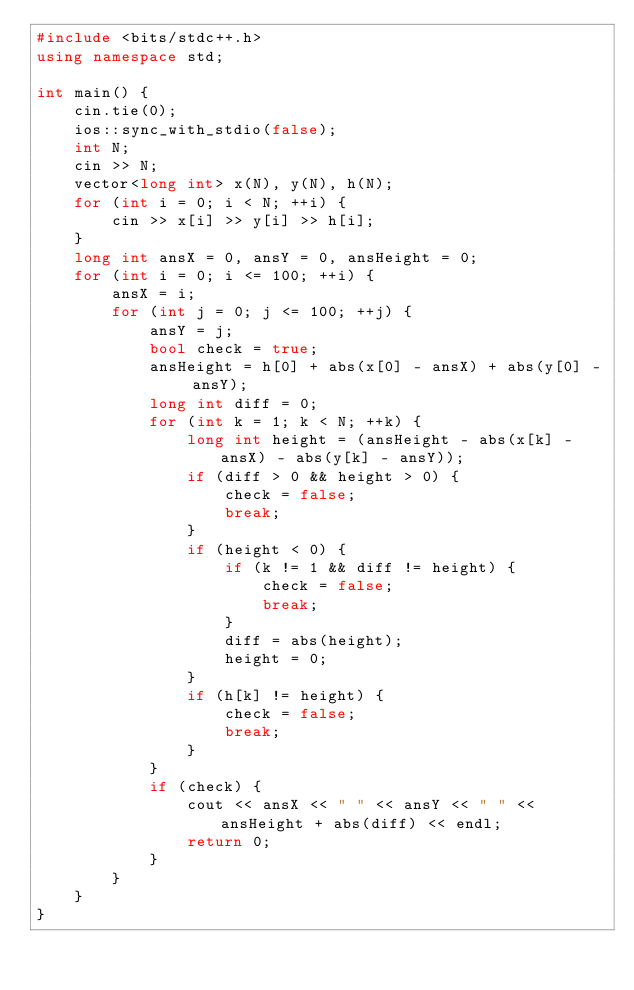Convert code to text. <code><loc_0><loc_0><loc_500><loc_500><_C++_>#include <bits/stdc++.h>
using namespace std;

int main() {
    cin.tie(0);
    ios::sync_with_stdio(false);
    int N;
    cin >> N;
    vector<long int> x(N), y(N), h(N);
    for (int i = 0; i < N; ++i) {
        cin >> x[i] >> y[i] >> h[i];
    }
    long int ansX = 0, ansY = 0, ansHeight = 0;
    for (int i = 0; i <= 100; ++i) {
        ansX = i;
        for (int j = 0; j <= 100; ++j) {
            ansY = j;
            bool check = true;
            ansHeight = h[0] + abs(x[0] - ansX) + abs(y[0] - ansY);
            long int diff = 0;
            for (int k = 1; k < N; ++k) {
                long int height = (ansHeight - abs(x[k] - ansX) - abs(y[k] - ansY));
                if (diff > 0 && height > 0) {
                    check = false;
                    break;
                }
                if (height < 0) {
                    if (k != 1 && diff != height) {
                        check = false;
                        break;
                    }
                    diff = abs(height);
                    height = 0;
                }
                if (h[k] != height) {
                    check = false;
                    break;
                }
            }
            if (check) {
                cout << ansX << " " << ansY << " " << ansHeight + abs(diff) << endl;
                return 0;
            }
        }
    }
}</code> 